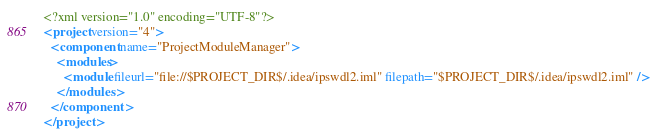<code> <loc_0><loc_0><loc_500><loc_500><_XML_><?xml version="1.0" encoding="UTF-8"?>
<project version="4">
  <component name="ProjectModuleManager">
    <modules>
      <module fileurl="file://$PROJECT_DIR$/.idea/ipswdl2.iml" filepath="$PROJECT_DIR$/.idea/ipswdl2.iml" />
    </modules>
  </component>
</project></code> 